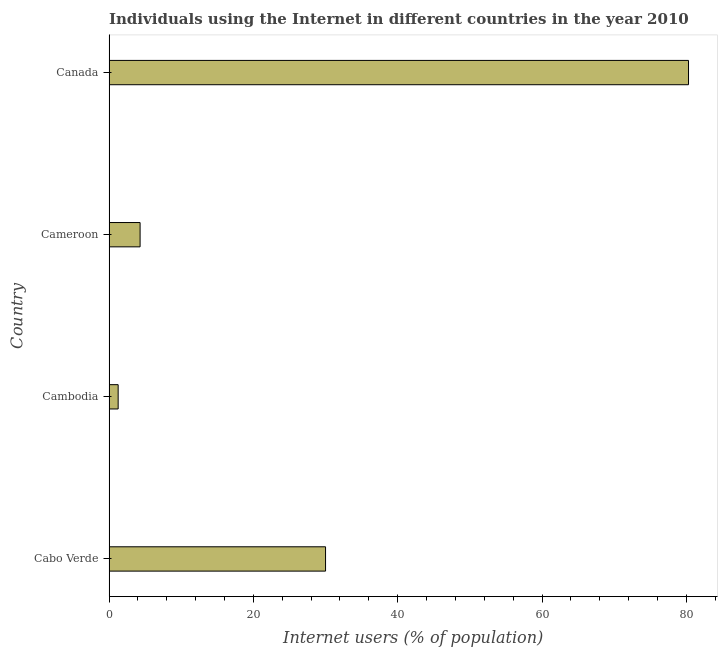Does the graph contain any zero values?
Your answer should be very brief. No. Does the graph contain grids?
Offer a terse response. No. What is the title of the graph?
Make the answer very short. Individuals using the Internet in different countries in the year 2010. What is the label or title of the X-axis?
Keep it short and to the point. Internet users (% of population). What is the label or title of the Y-axis?
Give a very brief answer. Country. What is the number of internet users in Canada?
Make the answer very short. 80.3. Across all countries, what is the maximum number of internet users?
Make the answer very short. 80.3. Across all countries, what is the minimum number of internet users?
Offer a terse response. 1.26. In which country was the number of internet users maximum?
Your answer should be compact. Canada. In which country was the number of internet users minimum?
Offer a very short reply. Cambodia. What is the sum of the number of internet users?
Give a very brief answer. 115.86. What is the difference between the number of internet users in Cabo Verde and Canada?
Your response must be concise. -50.3. What is the average number of internet users per country?
Provide a short and direct response. 28.96. What is the median number of internet users?
Ensure brevity in your answer.  17.15. What is the ratio of the number of internet users in Cabo Verde to that in Canada?
Provide a succinct answer. 0.37. Is the difference between the number of internet users in Cambodia and Canada greater than the difference between any two countries?
Provide a succinct answer. Yes. What is the difference between the highest and the second highest number of internet users?
Give a very brief answer. 50.3. Is the sum of the number of internet users in Cambodia and Cameroon greater than the maximum number of internet users across all countries?
Give a very brief answer. No. What is the difference between the highest and the lowest number of internet users?
Provide a short and direct response. 79.04. Are all the bars in the graph horizontal?
Offer a terse response. Yes. What is the difference between two consecutive major ticks on the X-axis?
Provide a succinct answer. 20. What is the Internet users (% of population) in Cabo Verde?
Keep it short and to the point. 30. What is the Internet users (% of population) of Cambodia?
Your response must be concise. 1.26. What is the Internet users (% of population) of Canada?
Give a very brief answer. 80.3. What is the difference between the Internet users (% of population) in Cabo Verde and Cambodia?
Give a very brief answer. 28.74. What is the difference between the Internet users (% of population) in Cabo Verde and Cameroon?
Ensure brevity in your answer.  25.7. What is the difference between the Internet users (% of population) in Cabo Verde and Canada?
Ensure brevity in your answer.  -50.3. What is the difference between the Internet users (% of population) in Cambodia and Cameroon?
Provide a succinct answer. -3.04. What is the difference between the Internet users (% of population) in Cambodia and Canada?
Offer a terse response. -79.04. What is the difference between the Internet users (% of population) in Cameroon and Canada?
Keep it short and to the point. -76. What is the ratio of the Internet users (% of population) in Cabo Verde to that in Cambodia?
Your answer should be very brief. 23.81. What is the ratio of the Internet users (% of population) in Cabo Verde to that in Cameroon?
Provide a short and direct response. 6.98. What is the ratio of the Internet users (% of population) in Cabo Verde to that in Canada?
Keep it short and to the point. 0.37. What is the ratio of the Internet users (% of population) in Cambodia to that in Cameroon?
Offer a terse response. 0.29. What is the ratio of the Internet users (% of population) in Cambodia to that in Canada?
Your answer should be very brief. 0.02. What is the ratio of the Internet users (% of population) in Cameroon to that in Canada?
Provide a short and direct response. 0.05. 